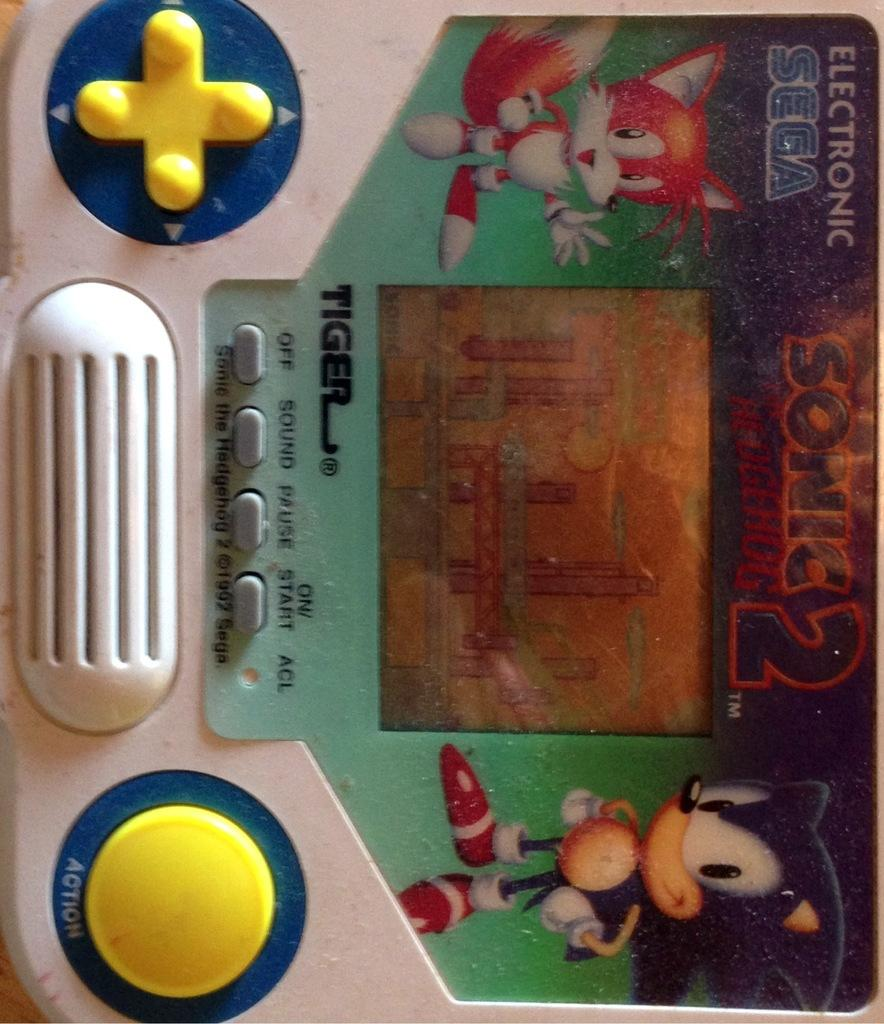What is the main subject of the image? The main subject of the image is a video game. What can be observed about the buttons on the video game? The buttons on the video game are in yellow color. Are there any additional decorations on the video game? Yes, there are cartoon stickers on the video game. How many frogs are sitting on the faucet in the image? There are no frogs or faucets present in the image; it features a video game with yellow buttons and cartoon stickers. What type of cow can be seen interacting with the video game in the image? There is no cow present in the image; it only features a video game with yellow buttons and cartoon stickers. 